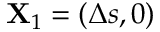<formula> <loc_0><loc_0><loc_500><loc_500>X _ { 1 } = ( \Delta { s } , 0 )</formula> 